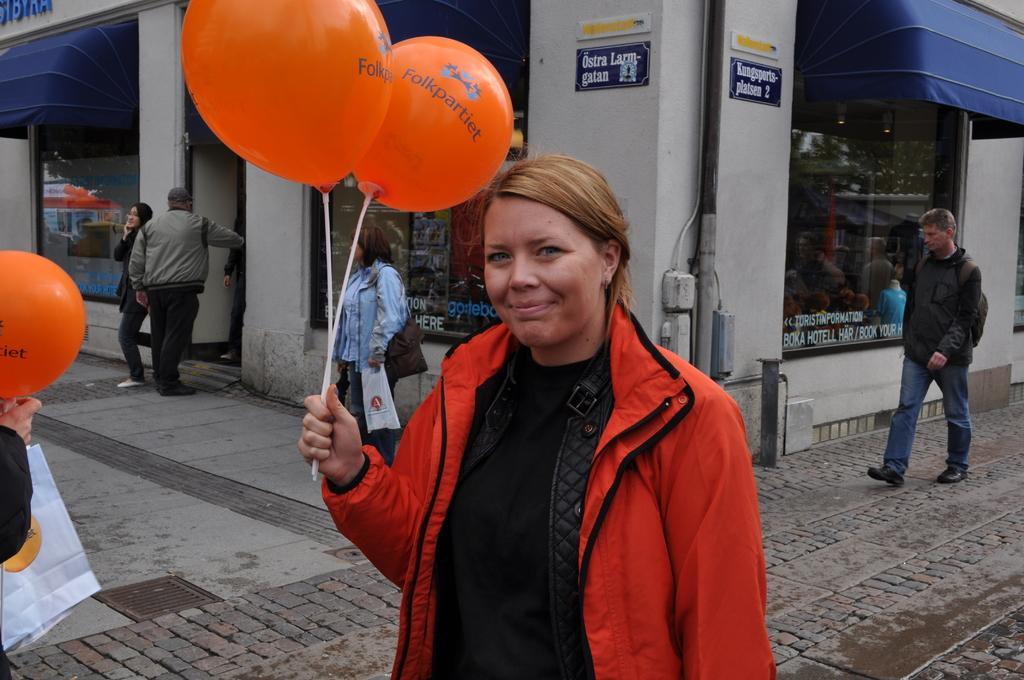Can you describe this image briefly? Here we can see a woman standing by holding two sticks of balloons in her hand. In the background there are three persons standing and a man on the right side is walking on the ground at the building and we can see glass doors,pipes,small boards on the wall. On the left we can see a person hand holding a balloon and there is a bag also. 